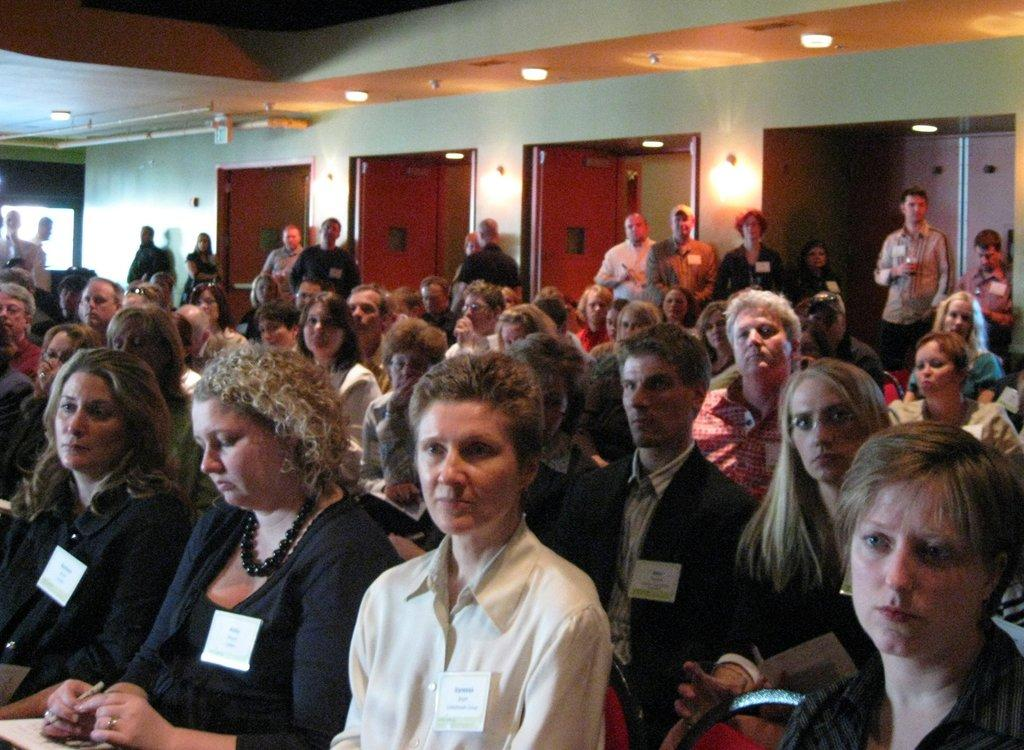How many people are in the image? There are multiple people in the image. What are the people in the image doing? Some people are standing, while others are sitting. What can be seen in the image that provides illumination? There are lights visible in the image. What architectural features can be seen in the image? There are doors visible in the image. What type of root is being discussed by the people in the image? There is no discussion or root present in the image. What is the range of the people in the image? The range of the people in the image cannot be determined, as the image does not provide any information about distances or areas. 